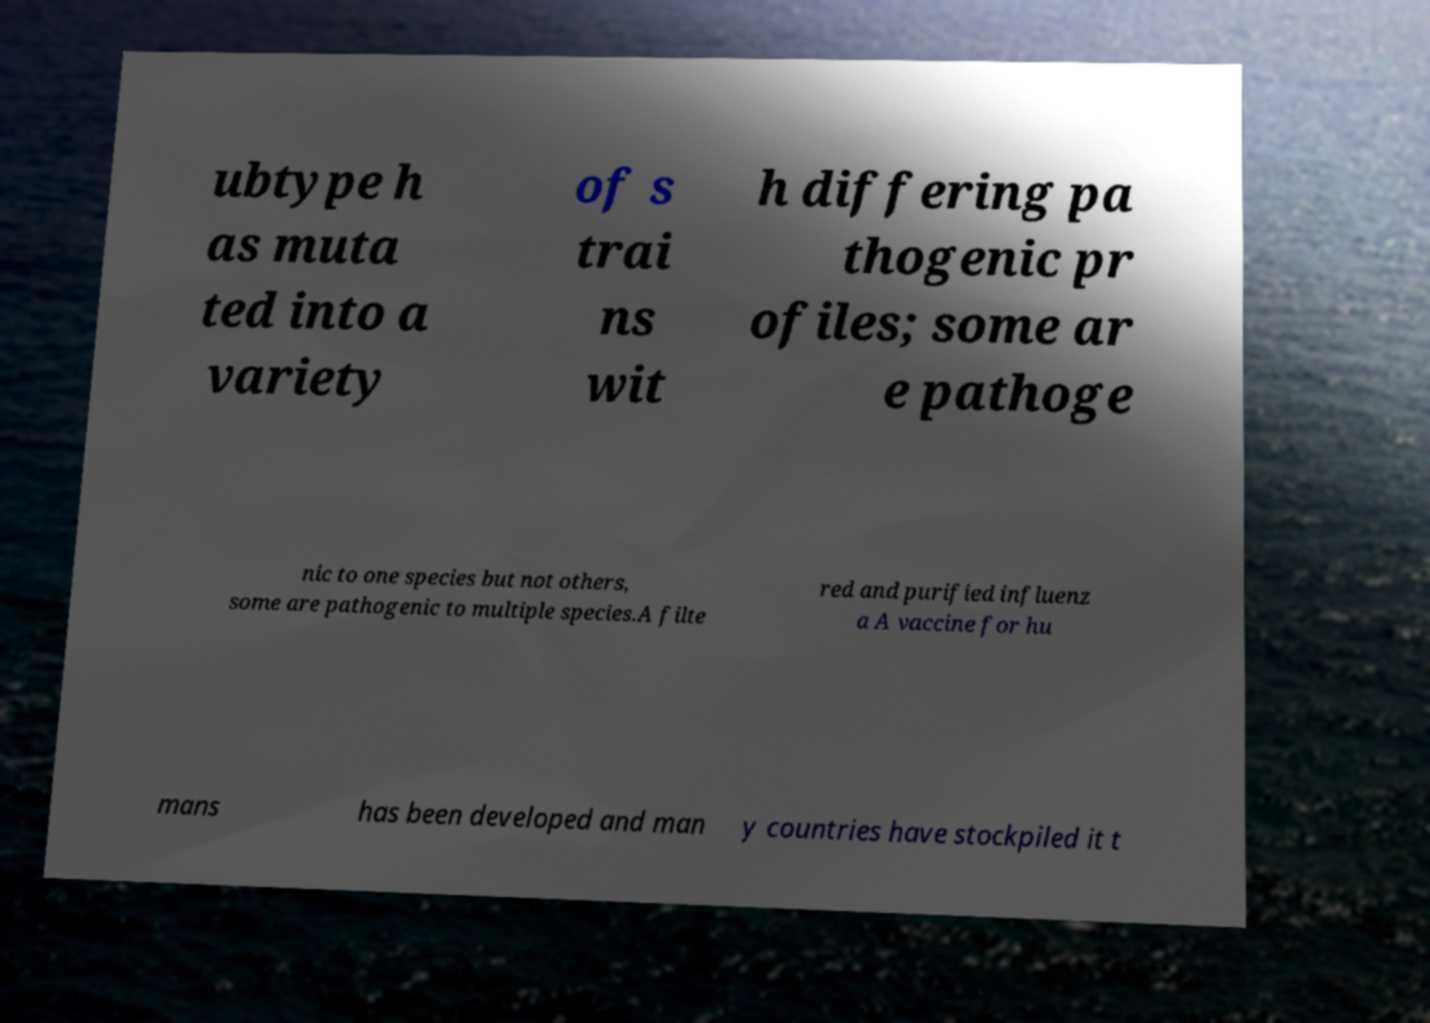Please identify and transcribe the text found in this image. ubtype h as muta ted into a variety of s trai ns wit h differing pa thogenic pr ofiles; some ar e pathoge nic to one species but not others, some are pathogenic to multiple species.A filte red and purified influenz a A vaccine for hu mans has been developed and man y countries have stockpiled it t 